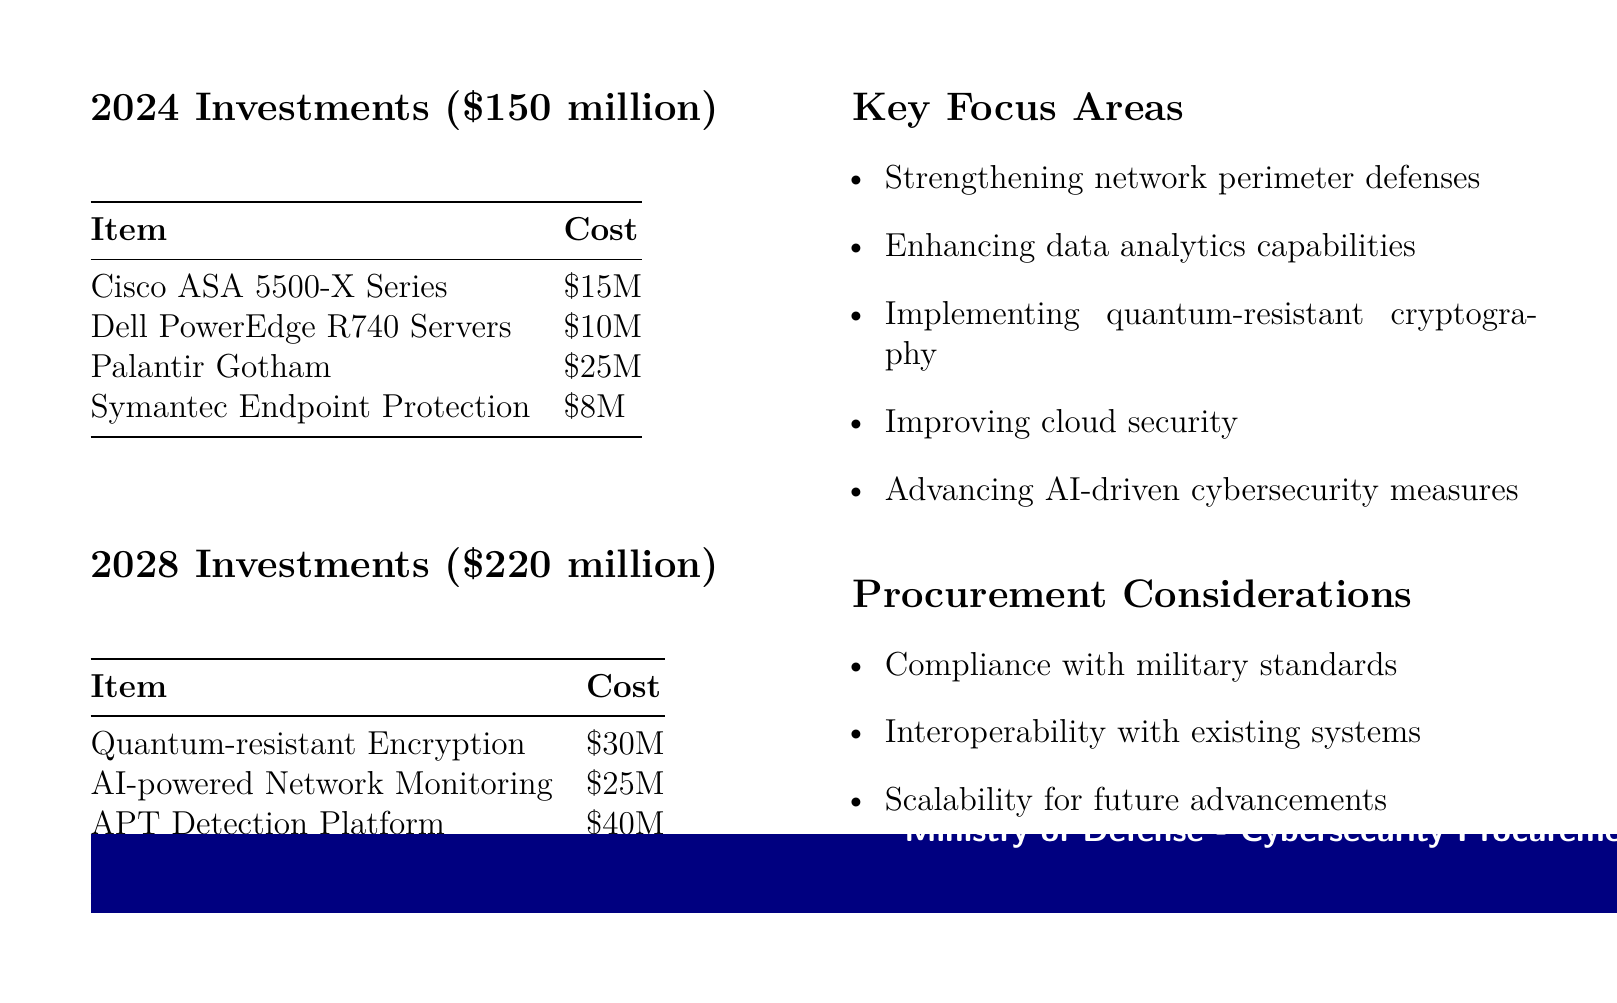What is the total budget for 2024 investments? The total budget for 2024 investments is explicitly stated in the document, which is $150 million.
Answer: $150 million What is the projected cost for the APT Detection Platform in 2028? The cost for the APT Detection Platform is provided in the 2028 investments section of the document, which is $40 million.
Answer: $40 million Which item has the highest cost in 2024 investments? The item with the highest cost in the 2024 investments is identified as Palantir Gotham, which costs $25 million.
Answer: Palantir Gotham What is one of the key focus areas for cybersecurity investments? The document lists key focus areas, including "Enhancing data analytics capabilities," as one of the areas of focus specified.
Answer: Enhancing data analytics capabilities What is the total budget for 2028 investments? The total budget for 2028 investments is mentioned in the document, which is $220 million.
Answer: $220 million What procurement consideration emphasizes future needs? One of the procurement considerations in the document specifically addresses "Scalability for future advancements," indicating its significance.
Answer: Scalability for future advancements How much is allocated for Quantum-resistant Encryption in 2028? The allocated amount for Quantum-resistant Encryption is provided in the 2028 investments section, which is $30 million.
Answer: $30 million What is the cost of Dell PowerEdge R740 Servers? The cost of the Dell PowerEdge R740 Servers is specified in the 2024 investments at $10 million.
Answer: $10 million 